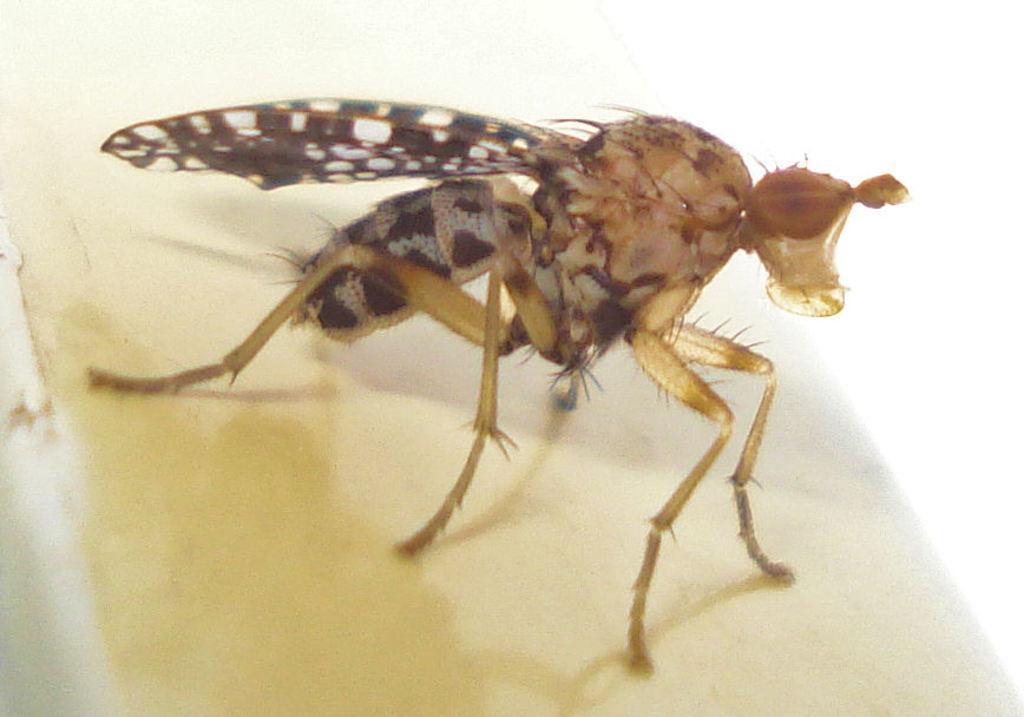Describe this image in one or two sentences. In this image we can see and an insect on the white color surface. 